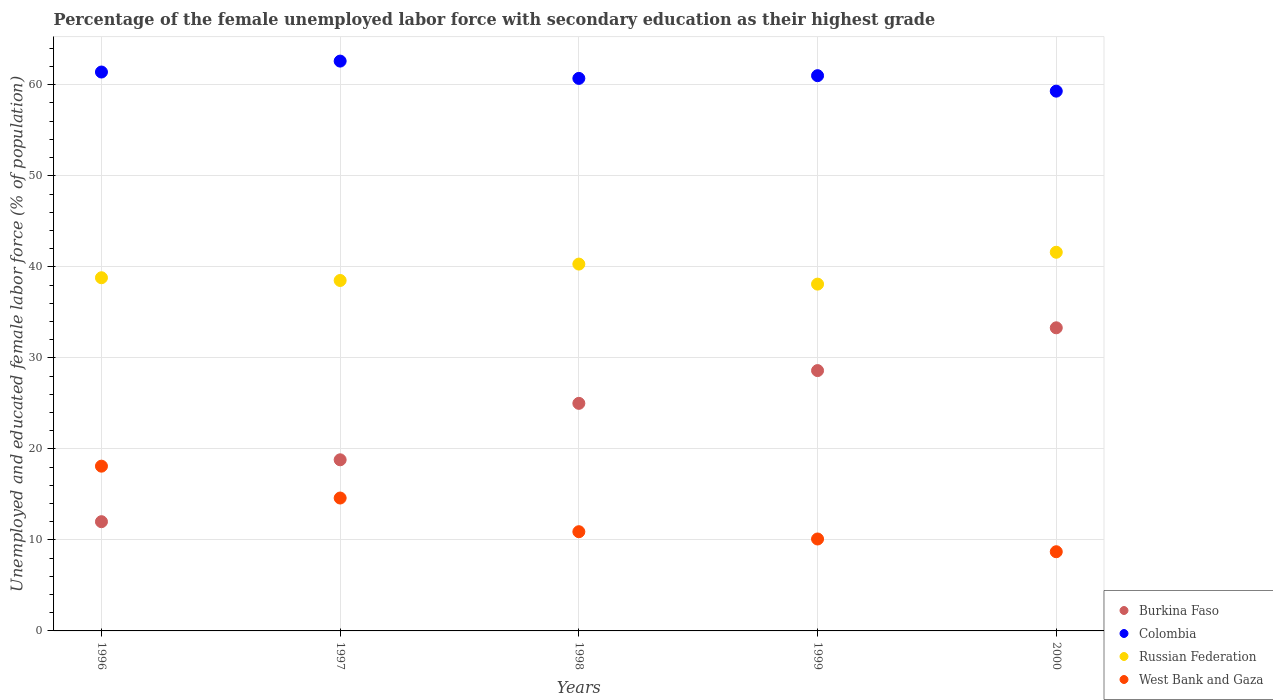Is the number of dotlines equal to the number of legend labels?
Provide a short and direct response. Yes. What is the percentage of the unemployed female labor force with secondary education in West Bank and Gaza in 2000?
Ensure brevity in your answer.  8.7. Across all years, what is the maximum percentage of the unemployed female labor force with secondary education in Colombia?
Your response must be concise. 62.6. Across all years, what is the minimum percentage of the unemployed female labor force with secondary education in West Bank and Gaza?
Make the answer very short. 8.7. In which year was the percentage of the unemployed female labor force with secondary education in West Bank and Gaza maximum?
Your answer should be compact. 1996. In which year was the percentage of the unemployed female labor force with secondary education in Colombia minimum?
Give a very brief answer. 2000. What is the total percentage of the unemployed female labor force with secondary education in Russian Federation in the graph?
Provide a succinct answer. 197.3. What is the difference between the percentage of the unemployed female labor force with secondary education in Colombia in 1998 and that in 2000?
Make the answer very short. 1.4. What is the difference between the percentage of the unemployed female labor force with secondary education in Russian Federation in 1999 and the percentage of the unemployed female labor force with secondary education in West Bank and Gaza in 1996?
Offer a terse response. 20. What is the average percentage of the unemployed female labor force with secondary education in West Bank and Gaza per year?
Your answer should be compact. 12.48. In the year 1998, what is the difference between the percentage of the unemployed female labor force with secondary education in Colombia and percentage of the unemployed female labor force with secondary education in Russian Federation?
Offer a very short reply. 20.4. In how many years, is the percentage of the unemployed female labor force with secondary education in West Bank and Gaza greater than 30 %?
Your answer should be compact. 0. What is the ratio of the percentage of the unemployed female labor force with secondary education in Russian Federation in 1998 to that in 2000?
Keep it short and to the point. 0.97. Is the difference between the percentage of the unemployed female labor force with secondary education in Colombia in 1997 and 2000 greater than the difference between the percentage of the unemployed female labor force with secondary education in Russian Federation in 1997 and 2000?
Ensure brevity in your answer.  Yes. What is the difference between the highest and the second highest percentage of the unemployed female labor force with secondary education in West Bank and Gaza?
Offer a very short reply. 3.5. In how many years, is the percentage of the unemployed female labor force with secondary education in Russian Federation greater than the average percentage of the unemployed female labor force with secondary education in Russian Federation taken over all years?
Keep it short and to the point. 2. Is the percentage of the unemployed female labor force with secondary education in West Bank and Gaza strictly greater than the percentage of the unemployed female labor force with secondary education in Burkina Faso over the years?
Offer a terse response. No. How many legend labels are there?
Your answer should be compact. 4. How are the legend labels stacked?
Offer a very short reply. Vertical. What is the title of the graph?
Ensure brevity in your answer.  Percentage of the female unemployed labor force with secondary education as their highest grade. Does "Congo (Democratic)" appear as one of the legend labels in the graph?
Offer a very short reply. No. What is the label or title of the X-axis?
Your answer should be very brief. Years. What is the label or title of the Y-axis?
Provide a short and direct response. Unemployed and educated female labor force (% of population). What is the Unemployed and educated female labor force (% of population) of Burkina Faso in 1996?
Your answer should be compact. 12. What is the Unemployed and educated female labor force (% of population) in Colombia in 1996?
Keep it short and to the point. 61.4. What is the Unemployed and educated female labor force (% of population) of Russian Federation in 1996?
Keep it short and to the point. 38.8. What is the Unemployed and educated female labor force (% of population) in West Bank and Gaza in 1996?
Provide a succinct answer. 18.1. What is the Unemployed and educated female labor force (% of population) in Burkina Faso in 1997?
Provide a succinct answer. 18.8. What is the Unemployed and educated female labor force (% of population) of Colombia in 1997?
Ensure brevity in your answer.  62.6. What is the Unemployed and educated female labor force (% of population) in Russian Federation in 1997?
Offer a terse response. 38.5. What is the Unemployed and educated female labor force (% of population) of West Bank and Gaza in 1997?
Keep it short and to the point. 14.6. What is the Unemployed and educated female labor force (% of population) in Colombia in 1998?
Your answer should be very brief. 60.7. What is the Unemployed and educated female labor force (% of population) of Russian Federation in 1998?
Offer a terse response. 40.3. What is the Unemployed and educated female labor force (% of population) in West Bank and Gaza in 1998?
Offer a very short reply. 10.9. What is the Unemployed and educated female labor force (% of population) in Burkina Faso in 1999?
Ensure brevity in your answer.  28.6. What is the Unemployed and educated female labor force (% of population) of Colombia in 1999?
Provide a succinct answer. 61. What is the Unemployed and educated female labor force (% of population) of Russian Federation in 1999?
Provide a succinct answer. 38.1. What is the Unemployed and educated female labor force (% of population) in West Bank and Gaza in 1999?
Your answer should be compact. 10.1. What is the Unemployed and educated female labor force (% of population) in Burkina Faso in 2000?
Your response must be concise. 33.3. What is the Unemployed and educated female labor force (% of population) of Colombia in 2000?
Offer a very short reply. 59.3. What is the Unemployed and educated female labor force (% of population) of Russian Federation in 2000?
Provide a short and direct response. 41.6. What is the Unemployed and educated female labor force (% of population) in West Bank and Gaza in 2000?
Offer a very short reply. 8.7. Across all years, what is the maximum Unemployed and educated female labor force (% of population) of Burkina Faso?
Your response must be concise. 33.3. Across all years, what is the maximum Unemployed and educated female labor force (% of population) of Colombia?
Offer a very short reply. 62.6. Across all years, what is the maximum Unemployed and educated female labor force (% of population) of Russian Federation?
Your answer should be very brief. 41.6. Across all years, what is the maximum Unemployed and educated female labor force (% of population) in West Bank and Gaza?
Your response must be concise. 18.1. Across all years, what is the minimum Unemployed and educated female labor force (% of population) in Colombia?
Your response must be concise. 59.3. Across all years, what is the minimum Unemployed and educated female labor force (% of population) of Russian Federation?
Your response must be concise. 38.1. Across all years, what is the minimum Unemployed and educated female labor force (% of population) of West Bank and Gaza?
Make the answer very short. 8.7. What is the total Unemployed and educated female labor force (% of population) of Burkina Faso in the graph?
Provide a short and direct response. 117.7. What is the total Unemployed and educated female labor force (% of population) of Colombia in the graph?
Your response must be concise. 305. What is the total Unemployed and educated female labor force (% of population) of Russian Federation in the graph?
Keep it short and to the point. 197.3. What is the total Unemployed and educated female labor force (% of population) in West Bank and Gaza in the graph?
Ensure brevity in your answer.  62.4. What is the difference between the Unemployed and educated female labor force (% of population) of Russian Federation in 1996 and that in 1997?
Your answer should be very brief. 0.3. What is the difference between the Unemployed and educated female labor force (% of population) in West Bank and Gaza in 1996 and that in 1997?
Make the answer very short. 3.5. What is the difference between the Unemployed and educated female labor force (% of population) in Burkina Faso in 1996 and that in 1999?
Make the answer very short. -16.6. What is the difference between the Unemployed and educated female labor force (% of population) of Colombia in 1996 and that in 1999?
Make the answer very short. 0.4. What is the difference between the Unemployed and educated female labor force (% of population) of Russian Federation in 1996 and that in 1999?
Provide a succinct answer. 0.7. What is the difference between the Unemployed and educated female labor force (% of population) of Burkina Faso in 1996 and that in 2000?
Provide a succinct answer. -21.3. What is the difference between the Unemployed and educated female labor force (% of population) of Colombia in 1996 and that in 2000?
Make the answer very short. 2.1. What is the difference between the Unemployed and educated female labor force (% of population) of West Bank and Gaza in 1996 and that in 2000?
Keep it short and to the point. 9.4. What is the difference between the Unemployed and educated female labor force (% of population) of Burkina Faso in 1997 and that in 1998?
Ensure brevity in your answer.  -6.2. What is the difference between the Unemployed and educated female labor force (% of population) in Colombia in 1997 and that in 1998?
Make the answer very short. 1.9. What is the difference between the Unemployed and educated female labor force (% of population) in Russian Federation in 1997 and that in 1998?
Your answer should be compact. -1.8. What is the difference between the Unemployed and educated female labor force (% of population) of West Bank and Gaza in 1997 and that in 1998?
Provide a succinct answer. 3.7. What is the difference between the Unemployed and educated female labor force (% of population) in Colombia in 1997 and that in 1999?
Offer a terse response. 1.6. What is the difference between the Unemployed and educated female labor force (% of population) of Burkina Faso in 1997 and that in 2000?
Give a very brief answer. -14.5. What is the difference between the Unemployed and educated female labor force (% of population) in West Bank and Gaza in 1997 and that in 2000?
Provide a succinct answer. 5.9. What is the difference between the Unemployed and educated female labor force (% of population) in West Bank and Gaza in 1998 and that in 1999?
Give a very brief answer. 0.8. What is the difference between the Unemployed and educated female labor force (% of population) in Burkina Faso in 1998 and that in 2000?
Provide a succinct answer. -8.3. What is the difference between the Unemployed and educated female labor force (% of population) in Colombia in 1998 and that in 2000?
Your response must be concise. 1.4. What is the difference between the Unemployed and educated female labor force (% of population) of West Bank and Gaza in 1998 and that in 2000?
Offer a terse response. 2.2. What is the difference between the Unemployed and educated female labor force (% of population) in Colombia in 1999 and that in 2000?
Your answer should be compact. 1.7. What is the difference between the Unemployed and educated female labor force (% of population) of Burkina Faso in 1996 and the Unemployed and educated female labor force (% of population) of Colombia in 1997?
Make the answer very short. -50.6. What is the difference between the Unemployed and educated female labor force (% of population) in Burkina Faso in 1996 and the Unemployed and educated female labor force (% of population) in Russian Federation in 1997?
Keep it short and to the point. -26.5. What is the difference between the Unemployed and educated female labor force (% of population) of Colombia in 1996 and the Unemployed and educated female labor force (% of population) of Russian Federation in 1997?
Offer a terse response. 22.9. What is the difference between the Unemployed and educated female labor force (% of population) in Colombia in 1996 and the Unemployed and educated female labor force (% of population) in West Bank and Gaza in 1997?
Your answer should be compact. 46.8. What is the difference between the Unemployed and educated female labor force (% of population) of Russian Federation in 1996 and the Unemployed and educated female labor force (% of population) of West Bank and Gaza in 1997?
Make the answer very short. 24.2. What is the difference between the Unemployed and educated female labor force (% of population) of Burkina Faso in 1996 and the Unemployed and educated female labor force (% of population) of Colombia in 1998?
Your answer should be compact. -48.7. What is the difference between the Unemployed and educated female labor force (% of population) in Burkina Faso in 1996 and the Unemployed and educated female labor force (% of population) in Russian Federation in 1998?
Keep it short and to the point. -28.3. What is the difference between the Unemployed and educated female labor force (% of population) in Colombia in 1996 and the Unemployed and educated female labor force (% of population) in Russian Federation in 1998?
Provide a short and direct response. 21.1. What is the difference between the Unemployed and educated female labor force (% of population) of Colombia in 1996 and the Unemployed and educated female labor force (% of population) of West Bank and Gaza in 1998?
Provide a succinct answer. 50.5. What is the difference between the Unemployed and educated female labor force (% of population) of Russian Federation in 1996 and the Unemployed and educated female labor force (% of population) of West Bank and Gaza in 1998?
Give a very brief answer. 27.9. What is the difference between the Unemployed and educated female labor force (% of population) of Burkina Faso in 1996 and the Unemployed and educated female labor force (% of population) of Colombia in 1999?
Your answer should be compact. -49. What is the difference between the Unemployed and educated female labor force (% of population) in Burkina Faso in 1996 and the Unemployed and educated female labor force (% of population) in Russian Federation in 1999?
Keep it short and to the point. -26.1. What is the difference between the Unemployed and educated female labor force (% of population) in Burkina Faso in 1996 and the Unemployed and educated female labor force (% of population) in West Bank and Gaza in 1999?
Your response must be concise. 1.9. What is the difference between the Unemployed and educated female labor force (% of population) in Colombia in 1996 and the Unemployed and educated female labor force (% of population) in Russian Federation in 1999?
Ensure brevity in your answer.  23.3. What is the difference between the Unemployed and educated female labor force (% of population) in Colombia in 1996 and the Unemployed and educated female labor force (% of population) in West Bank and Gaza in 1999?
Your answer should be compact. 51.3. What is the difference between the Unemployed and educated female labor force (% of population) of Russian Federation in 1996 and the Unemployed and educated female labor force (% of population) of West Bank and Gaza in 1999?
Ensure brevity in your answer.  28.7. What is the difference between the Unemployed and educated female labor force (% of population) of Burkina Faso in 1996 and the Unemployed and educated female labor force (% of population) of Colombia in 2000?
Offer a terse response. -47.3. What is the difference between the Unemployed and educated female labor force (% of population) in Burkina Faso in 1996 and the Unemployed and educated female labor force (% of population) in Russian Federation in 2000?
Your answer should be very brief. -29.6. What is the difference between the Unemployed and educated female labor force (% of population) in Burkina Faso in 1996 and the Unemployed and educated female labor force (% of population) in West Bank and Gaza in 2000?
Give a very brief answer. 3.3. What is the difference between the Unemployed and educated female labor force (% of population) of Colombia in 1996 and the Unemployed and educated female labor force (% of population) of Russian Federation in 2000?
Your answer should be compact. 19.8. What is the difference between the Unemployed and educated female labor force (% of population) of Colombia in 1996 and the Unemployed and educated female labor force (% of population) of West Bank and Gaza in 2000?
Make the answer very short. 52.7. What is the difference between the Unemployed and educated female labor force (% of population) in Russian Federation in 1996 and the Unemployed and educated female labor force (% of population) in West Bank and Gaza in 2000?
Ensure brevity in your answer.  30.1. What is the difference between the Unemployed and educated female labor force (% of population) in Burkina Faso in 1997 and the Unemployed and educated female labor force (% of population) in Colombia in 1998?
Offer a very short reply. -41.9. What is the difference between the Unemployed and educated female labor force (% of population) in Burkina Faso in 1997 and the Unemployed and educated female labor force (% of population) in Russian Federation in 1998?
Provide a short and direct response. -21.5. What is the difference between the Unemployed and educated female labor force (% of population) of Colombia in 1997 and the Unemployed and educated female labor force (% of population) of Russian Federation in 1998?
Provide a succinct answer. 22.3. What is the difference between the Unemployed and educated female labor force (% of population) in Colombia in 1997 and the Unemployed and educated female labor force (% of population) in West Bank and Gaza in 1998?
Offer a very short reply. 51.7. What is the difference between the Unemployed and educated female labor force (% of population) of Russian Federation in 1997 and the Unemployed and educated female labor force (% of population) of West Bank and Gaza in 1998?
Keep it short and to the point. 27.6. What is the difference between the Unemployed and educated female labor force (% of population) in Burkina Faso in 1997 and the Unemployed and educated female labor force (% of population) in Colombia in 1999?
Offer a very short reply. -42.2. What is the difference between the Unemployed and educated female labor force (% of population) of Burkina Faso in 1997 and the Unemployed and educated female labor force (% of population) of Russian Federation in 1999?
Ensure brevity in your answer.  -19.3. What is the difference between the Unemployed and educated female labor force (% of population) of Colombia in 1997 and the Unemployed and educated female labor force (% of population) of Russian Federation in 1999?
Offer a terse response. 24.5. What is the difference between the Unemployed and educated female labor force (% of population) in Colombia in 1997 and the Unemployed and educated female labor force (% of population) in West Bank and Gaza in 1999?
Your answer should be compact. 52.5. What is the difference between the Unemployed and educated female labor force (% of population) of Russian Federation in 1997 and the Unemployed and educated female labor force (% of population) of West Bank and Gaza in 1999?
Ensure brevity in your answer.  28.4. What is the difference between the Unemployed and educated female labor force (% of population) of Burkina Faso in 1997 and the Unemployed and educated female labor force (% of population) of Colombia in 2000?
Offer a very short reply. -40.5. What is the difference between the Unemployed and educated female labor force (% of population) in Burkina Faso in 1997 and the Unemployed and educated female labor force (% of population) in Russian Federation in 2000?
Provide a short and direct response. -22.8. What is the difference between the Unemployed and educated female labor force (% of population) of Colombia in 1997 and the Unemployed and educated female labor force (% of population) of West Bank and Gaza in 2000?
Ensure brevity in your answer.  53.9. What is the difference between the Unemployed and educated female labor force (% of population) of Russian Federation in 1997 and the Unemployed and educated female labor force (% of population) of West Bank and Gaza in 2000?
Your response must be concise. 29.8. What is the difference between the Unemployed and educated female labor force (% of population) of Burkina Faso in 1998 and the Unemployed and educated female labor force (% of population) of Colombia in 1999?
Give a very brief answer. -36. What is the difference between the Unemployed and educated female labor force (% of population) of Colombia in 1998 and the Unemployed and educated female labor force (% of population) of Russian Federation in 1999?
Make the answer very short. 22.6. What is the difference between the Unemployed and educated female labor force (% of population) in Colombia in 1998 and the Unemployed and educated female labor force (% of population) in West Bank and Gaza in 1999?
Keep it short and to the point. 50.6. What is the difference between the Unemployed and educated female labor force (% of population) in Russian Federation in 1998 and the Unemployed and educated female labor force (% of population) in West Bank and Gaza in 1999?
Give a very brief answer. 30.2. What is the difference between the Unemployed and educated female labor force (% of population) in Burkina Faso in 1998 and the Unemployed and educated female labor force (% of population) in Colombia in 2000?
Keep it short and to the point. -34.3. What is the difference between the Unemployed and educated female labor force (% of population) of Burkina Faso in 1998 and the Unemployed and educated female labor force (% of population) of Russian Federation in 2000?
Give a very brief answer. -16.6. What is the difference between the Unemployed and educated female labor force (% of population) in Colombia in 1998 and the Unemployed and educated female labor force (% of population) in West Bank and Gaza in 2000?
Your answer should be compact. 52. What is the difference between the Unemployed and educated female labor force (% of population) in Russian Federation in 1998 and the Unemployed and educated female labor force (% of population) in West Bank and Gaza in 2000?
Your answer should be very brief. 31.6. What is the difference between the Unemployed and educated female labor force (% of population) of Burkina Faso in 1999 and the Unemployed and educated female labor force (% of population) of Colombia in 2000?
Give a very brief answer. -30.7. What is the difference between the Unemployed and educated female labor force (% of population) in Burkina Faso in 1999 and the Unemployed and educated female labor force (% of population) in West Bank and Gaza in 2000?
Give a very brief answer. 19.9. What is the difference between the Unemployed and educated female labor force (% of population) of Colombia in 1999 and the Unemployed and educated female labor force (% of population) of West Bank and Gaza in 2000?
Your answer should be compact. 52.3. What is the difference between the Unemployed and educated female labor force (% of population) of Russian Federation in 1999 and the Unemployed and educated female labor force (% of population) of West Bank and Gaza in 2000?
Provide a succinct answer. 29.4. What is the average Unemployed and educated female labor force (% of population) in Burkina Faso per year?
Ensure brevity in your answer.  23.54. What is the average Unemployed and educated female labor force (% of population) in Russian Federation per year?
Offer a very short reply. 39.46. What is the average Unemployed and educated female labor force (% of population) of West Bank and Gaza per year?
Your response must be concise. 12.48. In the year 1996, what is the difference between the Unemployed and educated female labor force (% of population) of Burkina Faso and Unemployed and educated female labor force (% of population) of Colombia?
Your answer should be very brief. -49.4. In the year 1996, what is the difference between the Unemployed and educated female labor force (% of population) of Burkina Faso and Unemployed and educated female labor force (% of population) of Russian Federation?
Give a very brief answer. -26.8. In the year 1996, what is the difference between the Unemployed and educated female labor force (% of population) of Colombia and Unemployed and educated female labor force (% of population) of Russian Federation?
Your response must be concise. 22.6. In the year 1996, what is the difference between the Unemployed and educated female labor force (% of population) of Colombia and Unemployed and educated female labor force (% of population) of West Bank and Gaza?
Your answer should be compact. 43.3. In the year 1996, what is the difference between the Unemployed and educated female labor force (% of population) in Russian Federation and Unemployed and educated female labor force (% of population) in West Bank and Gaza?
Your answer should be compact. 20.7. In the year 1997, what is the difference between the Unemployed and educated female labor force (% of population) in Burkina Faso and Unemployed and educated female labor force (% of population) in Colombia?
Give a very brief answer. -43.8. In the year 1997, what is the difference between the Unemployed and educated female labor force (% of population) of Burkina Faso and Unemployed and educated female labor force (% of population) of Russian Federation?
Your response must be concise. -19.7. In the year 1997, what is the difference between the Unemployed and educated female labor force (% of population) in Burkina Faso and Unemployed and educated female labor force (% of population) in West Bank and Gaza?
Make the answer very short. 4.2. In the year 1997, what is the difference between the Unemployed and educated female labor force (% of population) in Colombia and Unemployed and educated female labor force (% of population) in Russian Federation?
Your response must be concise. 24.1. In the year 1997, what is the difference between the Unemployed and educated female labor force (% of population) of Russian Federation and Unemployed and educated female labor force (% of population) of West Bank and Gaza?
Keep it short and to the point. 23.9. In the year 1998, what is the difference between the Unemployed and educated female labor force (% of population) of Burkina Faso and Unemployed and educated female labor force (% of population) of Colombia?
Ensure brevity in your answer.  -35.7. In the year 1998, what is the difference between the Unemployed and educated female labor force (% of population) of Burkina Faso and Unemployed and educated female labor force (% of population) of Russian Federation?
Your answer should be very brief. -15.3. In the year 1998, what is the difference between the Unemployed and educated female labor force (% of population) in Burkina Faso and Unemployed and educated female labor force (% of population) in West Bank and Gaza?
Your answer should be compact. 14.1. In the year 1998, what is the difference between the Unemployed and educated female labor force (% of population) in Colombia and Unemployed and educated female labor force (% of population) in Russian Federation?
Give a very brief answer. 20.4. In the year 1998, what is the difference between the Unemployed and educated female labor force (% of population) in Colombia and Unemployed and educated female labor force (% of population) in West Bank and Gaza?
Your response must be concise. 49.8. In the year 1998, what is the difference between the Unemployed and educated female labor force (% of population) of Russian Federation and Unemployed and educated female labor force (% of population) of West Bank and Gaza?
Keep it short and to the point. 29.4. In the year 1999, what is the difference between the Unemployed and educated female labor force (% of population) in Burkina Faso and Unemployed and educated female labor force (% of population) in Colombia?
Make the answer very short. -32.4. In the year 1999, what is the difference between the Unemployed and educated female labor force (% of population) of Burkina Faso and Unemployed and educated female labor force (% of population) of Russian Federation?
Give a very brief answer. -9.5. In the year 1999, what is the difference between the Unemployed and educated female labor force (% of population) of Burkina Faso and Unemployed and educated female labor force (% of population) of West Bank and Gaza?
Offer a terse response. 18.5. In the year 1999, what is the difference between the Unemployed and educated female labor force (% of population) in Colombia and Unemployed and educated female labor force (% of population) in Russian Federation?
Provide a short and direct response. 22.9. In the year 1999, what is the difference between the Unemployed and educated female labor force (% of population) in Colombia and Unemployed and educated female labor force (% of population) in West Bank and Gaza?
Keep it short and to the point. 50.9. In the year 2000, what is the difference between the Unemployed and educated female labor force (% of population) of Burkina Faso and Unemployed and educated female labor force (% of population) of Colombia?
Your answer should be compact. -26. In the year 2000, what is the difference between the Unemployed and educated female labor force (% of population) of Burkina Faso and Unemployed and educated female labor force (% of population) of West Bank and Gaza?
Your answer should be very brief. 24.6. In the year 2000, what is the difference between the Unemployed and educated female labor force (% of population) of Colombia and Unemployed and educated female labor force (% of population) of Russian Federation?
Make the answer very short. 17.7. In the year 2000, what is the difference between the Unemployed and educated female labor force (% of population) in Colombia and Unemployed and educated female labor force (% of population) in West Bank and Gaza?
Provide a succinct answer. 50.6. In the year 2000, what is the difference between the Unemployed and educated female labor force (% of population) in Russian Federation and Unemployed and educated female labor force (% of population) in West Bank and Gaza?
Your answer should be very brief. 32.9. What is the ratio of the Unemployed and educated female labor force (% of population) of Burkina Faso in 1996 to that in 1997?
Your response must be concise. 0.64. What is the ratio of the Unemployed and educated female labor force (% of population) of Colombia in 1996 to that in 1997?
Provide a succinct answer. 0.98. What is the ratio of the Unemployed and educated female labor force (% of population) of West Bank and Gaza in 1996 to that in 1997?
Your answer should be very brief. 1.24. What is the ratio of the Unemployed and educated female labor force (% of population) in Burkina Faso in 1996 to that in 1998?
Your answer should be compact. 0.48. What is the ratio of the Unemployed and educated female labor force (% of population) of Colombia in 1996 to that in 1998?
Offer a terse response. 1.01. What is the ratio of the Unemployed and educated female labor force (% of population) in Russian Federation in 1996 to that in 1998?
Make the answer very short. 0.96. What is the ratio of the Unemployed and educated female labor force (% of population) of West Bank and Gaza in 1996 to that in 1998?
Give a very brief answer. 1.66. What is the ratio of the Unemployed and educated female labor force (% of population) of Burkina Faso in 1996 to that in 1999?
Give a very brief answer. 0.42. What is the ratio of the Unemployed and educated female labor force (% of population) in Colombia in 1996 to that in 1999?
Offer a terse response. 1.01. What is the ratio of the Unemployed and educated female labor force (% of population) in Russian Federation in 1996 to that in 1999?
Your answer should be very brief. 1.02. What is the ratio of the Unemployed and educated female labor force (% of population) of West Bank and Gaza in 1996 to that in 1999?
Keep it short and to the point. 1.79. What is the ratio of the Unemployed and educated female labor force (% of population) of Burkina Faso in 1996 to that in 2000?
Give a very brief answer. 0.36. What is the ratio of the Unemployed and educated female labor force (% of population) of Colombia in 1996 to that in 2000?
Offer a terse response. 1.04. What is the ratio of the Unemployed and educated female labor force (% of population) in Russian Federation in 1996 to that in 2000?
Offer a very short reply. 0.93. What is the ratio of the Unemployed and educated female labor force (% of population) of West Bank and Gaza in 1996 to that in 2000?
Make the answer very short. 2.08. What is the ratio of the Unemployed and educated female labor force (% of population) in Burkina Faso in 1997 to that in 1998?
Your answer should be very brief. 0.75. What is the ratio of the Unemployed and educated female labor force (% of population) in Colombia in 1997 to that in 1998?
Give a very brief answer. 1.03. What is the ratio of the Unemployed and educated female labor force (% of population) in Russian Federation in 1997 to that in 1998?
Ensure brevity in your answer.  0.96. What is the ratio of the Unemployed and educated female labor force (% of population) in West Bank and Gaza in 1997 to that in 1998?
Offer a very short reply. 1.34. What is the ratio of the Unemployed and educated female labor force (% of population) of Burkina Faso in 1997 to that in 1999?
Your response must be concise. 0.66. What is the ratio of the Unemployed and educated female labor force (% of population) of Colombia in 1997 to that in 1999?
Make the answer very short. 1.03. What is the ratio of the Unemployed and educated female labor force (% of population) of Russian Federation in 1997 to that in 1999?
Ensure brevity in your answer.  1.01. What is the ratio of the Unemployed and educated female labor force (% of population) of West Bank and Gaza in 1997 to that in 1999?
Your response must be concise. 1.45. What is the ratio of the Unemployed and educated female labor force (% of population) of Burkina Faso in 1997 to that in 2000?
Your answer should be very brief. 0.56. What is the ratio of the Unemployed and educated female labor force (% of population) of Colombia in 1997 to that in 2000?
Offer a terse response. 1.06. What is the ratio of the Unemployed and educated female labor force (% of population) of Russian Federation in 1997 to that in 2000?
Your answer should be compact. 0.93. What is the ratio of the Unemployed and educated female labor force (% of population) in West Bank and Gaza in 1997 to that in 2000?
Keep it short and to the point. 1.68. What is the ratio of the Unemployed and educated female labor force (% of population) of Burkina Faso in 1998 to that in 1999?
Your answer should be very brief. 0.87. What is the ratio of the Unemployed and educated female labor force (% of population) of Colombia in 1998 to that in 1999?
Keep it short and to the point. 1. What is the ratio of the Unemployed and educated female labor force (% of population) in Russian Federation in 1998 to that in 1999?
Your answer should be very brief. 1.06. What is the ratio of the Unemployed and educated female labor force (% of population) of West Bank and Gaza in 1998 to that in 1999?
Provide a short and direct response. 1.08. What is the ratio of the Unemployed and educated female labor force (% of population) of Burkina Faso in 1998 to that in 2000?
Provide a succinct answer. 0.75. What is the ratio of the Unemployed and educated female labor force (% of population) in Colombia in 1998 to that in 2000?
Provide a succinct answer. 1.02. What is the ratio of the Unemployed and educated female labor force (% of population) of Russian Federation in 1998 to that in 2000?
Your answer should be very brief. 0.97. What is the ratio of the Unemployed and educated female labor force (% of population) in West Bank and Gaza in 1998 to that in 2000?
Ensure brevity in your answer.  1.25. What is the ratio of the Unemployed and educated female labor force (% of population) of Burkina Faso in 1999 to that in 2000?
Give a very brief answer. 0.86. What is the ratio of the Unemployed and educated female labor force (% of population) in Colombia in 1999 to that in 2000?
Give a very brief answer. 1.03. What is the ratio of the Unemployed and educated female labor force (% of population) in Russian Federation in 1999 to that in 2000?
Provide a short and direct response. 0.92. What is the ratio of the Unemployed and educated female labor force (% of population) of West Bank and Gaza in 1999 to that in 2000?
Offer a terse response. 1.16. What is the difference between the highest and the second highest Unemployed and educated female labor force (% of population) in West Bank and Gaza?
Offer a very short reply. 3.5. What is the difference between the highest and the lowest Unemployed and educated female labor force (% of population) in Burkina Faso?
Your answer should be very brief. 21.3. What is the difference between the highest and the lowest Unemployed and educated female labor force (% of population) of Colombia?
Your answer should be compact. 3.3. What is the difference between the highest and the lowest Unemployed and educated female labor force (% of population) of Russian Federation?
Offer a very short reply. 3.5. What is the difference between the highest and the lowest Unemployed and educated female labor force (% of population) of West Bank and Gaza?
Provide a succinct answer. 9.4. 